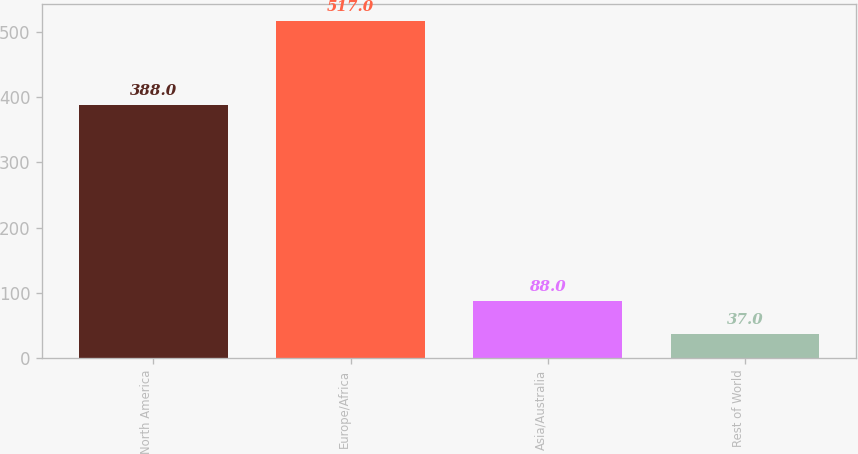Convert chart. <chart><loc_0><loc_0><loc_500><loc_500><bar_chart><fcel>North America<fcel>Europe/Africa<fcel>Asia/Australia<fcel>Rest of World<nl><fcel>388<fcel>517<fcel>88<fcel>37<nl></chart> 